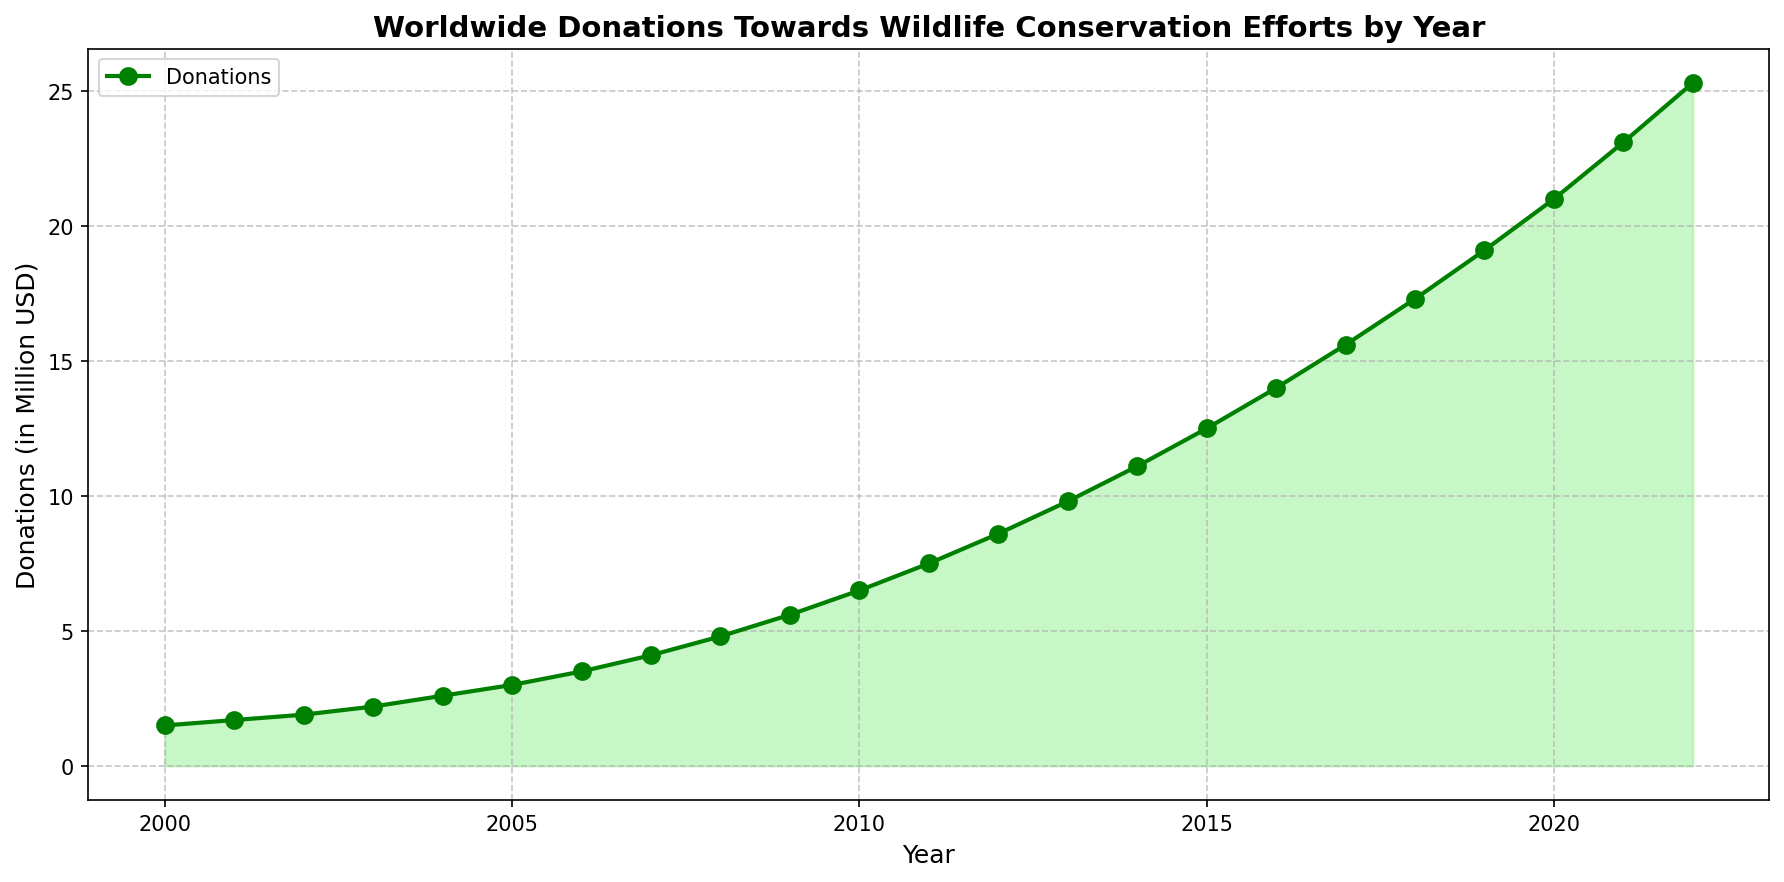What is the trend of worldwide donations towards wildlife conservation efforts from 2000 to 2022? The plot shows an upward trend, with donations increasing every year from 1.5 million USD in 2000 to 25.3 million USD in 2022.
Answer: Increasing trend What was the donation amount in 2015? Observing the plotted line at the year 2015, the donation amount was 12.5 million USD.
Answer: 12.5 million USD How much more were the donations in 2022 compared to 2010? Donations in 2022 were 25.3 million USD, and in 2010, they were 6.5 million USD. The difference is 25.3 - 6.5 = 18.8 million USD.
Answer: 18.8 million USD Which year saw the highest yearly increase in donations? From the plot, the biggest yearly increase can be observed between 2021 (23.1 million USD) and 2022 (25.3 million USD), an increase of 2.2 million USD.
Answer: 2022 What is the average donation amount from 2000 to 2022? Sum all the yearly donation amounts and then divide by the number of years (23). The average is (1.5 + 1.7 + 1.9 + 2.2 + 2.6 + 3.0 + 3.5 + 4.1 + 4.8 + 5.6 + 6.5 + 7.5 + 8.6 + 9.8 + 11.1 + 12.5 + 14.0 + 15.6 + 17.3 + 19.1 + 21.0 + 23.1 + 25.3) / 23. This equals 10.76 million USD.
Answer: 10.76 million USD What was the donation amount difference between the start year (2000) and the midpoint year (2011)? The donation in 2000 was 1.5 million USD and in 2011, it was 7.5 million USD. The difference is 7.5 - 1.5 = 6 million USD.
Answer: 6 million USD Did donations double at any point between 2000 and 2022? The closest double increment observed is between 2004 (2.6 million USD) and 2008 (4.8 million USD).
Answer: No exact doubling What year marks the first time donations exceeded 10 million USD? The donations exceed 10 million USD for the first time in 2014, with an amount of 11.1 million USD.
Answer: 2014 What is the total donation amount from 2010 through 2015? Sum the donation amounts from those years: 6.5 + 7.5 + 8.6 + 9.8 + 11.1 + 12.5 = 56 million USD.
Answer: 56 million USD Which year had the smallest increase from its previous year and what was the amount? The smallest increase is between 2001 (1.7 million USD) and 2002 (1.9 million USD), which is 0.2 million USD.
Answer: 2002, 0.2 million USD 